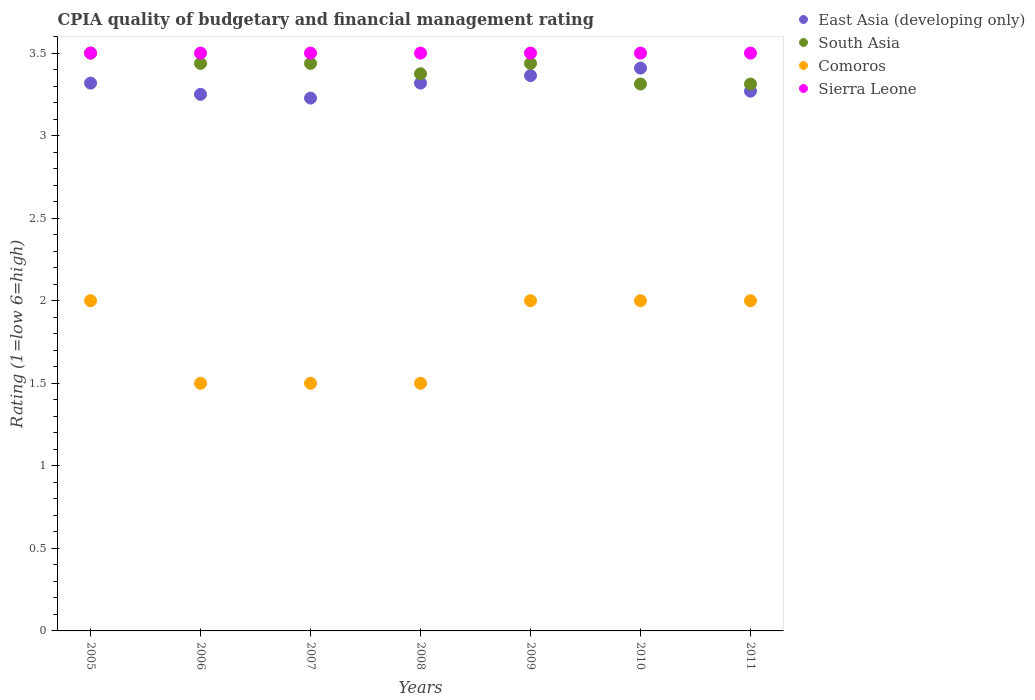How many different coloured dotlines are there?
Ensure brevity in your answer.  4. Is the number of dotlines equal to the number of legend labels?
Make the answer very short. Yes. What is the CPIA rating in East Asia (developing only) in 2008?
Your response must be concise. 3.32. Across all years, what is the maximum CPIA rating in South Asia?
Give a very brief answer. 3.5. In which year was the CPIA rating in South Asia maximum?
Offer a very short reply. 2005. In which year was the CPIA rating in Sierra Leone minimum?
Make the answer very short. 2005. What is the total CPIA rating in Sierra Leone in the graph?
Provide a short and direct response. 24.5. What is the average CPIA rating in Sierra Leone per year?
Keep it short and to the point. 3.5. In the year 2011, what is the difference between the CPIA rating in East Asia (developing only) and CPIA rating in South Asia?
Your response must be concise. -0.04. In how many years, is the CPIA rating in Sierra Leone greater than 0.7?
Offer a terse response. 7. What is the ratio of the CPIA rating in South Asia in 2008 to that in 2009?
Your answer should be very brief. 0.98. What is the difference between the highest and the second highest CPIA rating in South Asia?
Your answer should be very brief. 0.06. What is the difference between the highest and the lowest CPIA rating in South Asia?
Offer a terse response. 0.19. Is it the case that in every year, the sum of the CPIA rating in Comoros and CPIA rating in South Asia  is greater than the sum of CPIA rating in East Asia (developing only) and CPIA rating in Sierra Leone?
Offer a very short reply. No. Is it the case that in every year, the sum of the CPIA rating in East Asia (developing only) and CPIA rating in Comoros  is greater than the CPIA rating in South Asia?
Your answer should be very brief. Yes. Does the CPIA rating in Comoros monotonically increase over the years?
Your answer should be very brief. No. Is the CPIA rating in South Asia strictly less than the CPIA rating in East Asia (developing only) over the years?
Keep it short and to the point. No. How many years are there in the graph?
Your answer should be very brief. 7. What is the difference between two consecutive major ticks on the Y-axis?
Provide a succinct answer. 0.5. Are the values on the major ticks of Y-axis written in scientific E-notation?
Give a very brief answer. No. Does the graph contain grids?
Your response must be concise. No. What is the title of the graph?
Your response must be concise. CPIA quality of budgetary and financial management rating. What is the label or title of the Y-axis?
Keep it short and to the point. Rating (1=low 6=high). What is the Rating (1=low 6=high) in East Asia (developing only) in 2005?
Provide a short and direct response. 3.32. What is the Rating (1=low 6=high) of Comoros in 2005?
Provide a short and direct response. 2. What is the Rating (1=low 6=high) of Sierra Leone in 2005?
Your answer should be very brief. 3.5. What is the Rating (1=low 6=high) of East Asia (developing only) in 2006?
Provide a succinct answer. 3.25. What is the Rating (1=low 6=high) of South Asia in 2006?
Make the answer very short. 3.44. What is the Rating (1=low 6=high) in Comoros in 2006?
Your answer should be compact. 1.5. What is the Rating (1=low 6=high) in East Asia (developing only) in 2007?
Give a very brief answer. 3.23. What is the Rating (1=low 6=high) in South Asia in 2007?
Make the answer very short. 3.44. What is the Rating (1=low 6=high) in Sierra Leone in 2007?
Ensure brevity in your answer.  3.5. What is the Rating (1=low 6=high) in East Asia (developing only) in 2008?
Provide a short and direct response. 3.32. What is the Rating (1=low 6=high) of South Asia in 2008?
Provide a succinct answer. 3.38. What is the Rating (1=low 6=high) in Comoros in 2008?
Make the answer very short. 1.5. What is the Rating (1=low 6=high) of East Asia (developing only) in 2009?
Your answer should be compact. 3.36. What is the Rating (1=low 6=high) of South Asia in 2009?
Offer a very short reply. 3.44. What is the Rating (1=low 6=high) of Comoros in 2009?
Offer a very short reply. 2. What is the Rating (1=low 6=high) of Sierra Leone in 2009?
Your answer should be very brief. 3.5. What is the Rating (1=low 6=high) of East Asia (developing only) in 2010?
Keep it short and to the point. 3.41. What is the Rating (1=low 6=high) in South Asia in 2010?
Your answer should be compact. 3.31. What is the Rating (1=low 6=high) of Sierra Leone in 2010?
Give a very brief answer. 3.5. What is the Rating (1=low 6=high) of East Asia (developing only) in 2011?
Provide a succinct answer. 3.27. What is the Rating (1=low 6=high) of South Asia in 2011?
Give a very brief answer. 3.31. What is the Rating (1=low 6=high) in Sierra Leone in 2011?
Keep it short and to the point. 3.5. Across all years, what is the maximum Rating (1=low 6=high) of East Asia (developing only)?
Offer a terse response. 3.41. Across all years, what is the minimum Rating (1=low 6=high) in East Asia (developing only)?
Provide a short and direct response. 3.23. Across all years, what is the minimum Rating (1=low 6=high) of South Asia?
Offer a terse response. 3.31. What is the total Rating (1=low 6=high) of East Asia (developing only) in the graph?
Offer a terse response. 23.16. What is the total Rating (1=low 6=high) in South Asia in the graph?
Your answer should be very brief. 23.81. What is the difference between the Rating (1=low 6=high) in East Asia (developing only) in 2005 and that in 2006?
Your answer should be compact. 0.07. What is the difference between the Rating (1=low 6=high) of South Asia in 2005 and that in 2006?
Offer a very short reply. 0.06. What is the difference between the Rating (1=low 6=high) of Comoros in 2005 and that in 2006?
Your answer should be compact. 0.5. What is the difference between the Rating (1=low 6=high) in East Asia (developing only) in 2005 and that in 2007?
Provide a succinct answer. 0.09. What is the difference between the Rating (1=low 6=high) in South Asia in 2005 and that in 2007?
Your response must be concise. 0.06. What is the difference between the Rating (1=low 6=high) in Sierra Leone in 2005 and that in 2007?
Offer a very short reply. 0. What is the difference between the Rating (1=low 6=high) of East Asia (developing only) in 2005 and that in 2009?
Provide a succinct answer. -0.05. What is the difference between the Rating (1=low 6=high) in South Asia in 2005 and that in 2009?
Provide a succinct answer. 0.06. What is the difference between the Rating (1=low 6=high) in Comoros in 2005 and that in 2009?
Make the answer very short. 0. What is the difference between the Rating (1=low 6=high) in East Asia (developing only) in 2005 and that in 2010?
Your answer should be compact. -0.09. What is the difference between the Rating (1=low 6=high) in South Asia in 2005 and that in 2010?
Your answer should be compact. 0.19. What is the difference between the Rating (1=low 6=high) of Comoros in 2005 and that in 2010?
Give a very brief answer. 0. What is the difference between the Rating (1=low 6=high) of East Asia (developing only) in 2005 and that in 2011?
Offer a terse response. 0.05. What is the difference between the Rating (1=low 6=high) of South Asia in 2005 and that in 2011?
Your answer should be compact. 0.19. What is the difference between the Rating (1=low 6=high) of Comoros in 2005 and that in 2011?
Give a very brief answer. 0. What is the difference between the Rating (1=low 6=high) of East Asia (developing only) in 2006 and that in 2007?
Ensure brevity in your answer.  0.02. What is the difference between the Rating (1=low 6=high) of Sierra Leone in 2006 and that in 2007?
Ensure brevity in your answer.  0. What is the difference between the Rating (1=low 6=high) of East Asia (developing only) in 2006 and that in 2008?
Provide a short and direct response. -0.07. What is the difference between the Rating (1=low 6=high) of South Asia in 2006 and that in 2008?
Your answer should be very brief. 0.06. What is the difference between the Rating (1=low 6=high) in Comoros in 2006 and that in 2008?
Give a very brief answer. 0. What is the difference between the Rating (1=low 6=high) in Sierra Leone in 2006 and that in 2008?
Make the answer very short. 0. What is the difference between the Rating (1=low 6=high) of East Asia (developing only) in 2006 and that in 2009?
Keep it short and to the point. -0.11. What is the difference between the Rating (1=low 6=high) in South Asia in 2006 and that in 2009?
Offer a terse response. 0. What is the difference between the Rating (1=low 6=high) of Comoros in 2006 and that in 2009?
Keep it short and to the point. -0.5. What is the difference between the Rating (1=low 6=high) of Sierra Leone in 2006 and that in 2009?
Provide a short and direct response. 0. What is the difference between the Rating (1=low 6=high) in East Asia (developing only) in 2006 and that in 2010?
Make the answer very short. -0.16. What is the difference between the Rating (1=low 6=high) of Comoros in 2006 and that in 2010?
Provide a succinct answer. -0.5. What is the difference between the Rating (1=low 6=high) of Sierra Leone in 2006 and that in 2010?
Ensure brevity in your answer.  0. What is the difference between the Rating (1=low 6=high) of East Asia (developing only) in 2006 and that in 2011?
Give a very brief answer. -0.02. What is the difference between the Rating (1=low 6=high) of East Asia (developing only) in 2007 and that in 2008?
Give a very brief answer. -0.09. What is the difference between the Rating (1=low 6=high) of South Asia in 2007 and that in 2008?
Offer a terse response. 0.06. What is the difference between the Rating (1=low 6=high) in Comoros in 2007 and that in 2008?
Your response must be concise. 0. What is the difference between the Rating (1=low 6=high) in Sierra Leone in 2007 and that in 2008?
Offer a terse response. 0. What is the difference between the Rating (1=low 6=high) in East Asia (developing only) in 2007 and that in 2009?
Ensure brevity in your answer.  -0.14. What is the difference between the Rating (1=low 6=high) in South Asia in 2007 and that in 2009?
Ensure brevity in your answer.  0. What is the difference between the Rating (1=low 6=high) of Comoros in 2007 and that in 2009?
Offer a very short reply. -0.5. What is the difference between the Rating (1=low 6=high) in East Asia (developing only) in 2007 and that in 2010?
Ensure brevity in your answer.  -0.18. What is the difference between the Rating (1=low 6=high) of South Asia in 2007 and that in 2010?
Make the answer very short. 0.12. What is the difference between the Rating (1=low 6=high) of Comoros in 2007 and that in 2010?
Offer a very short reply. -0.5. What is the difference between the Rating (1=low 6=high) in Sierra Leone in 2007 and that in 2010?
Provide a short and direct response. 0. What is the difference between the Rating (1=low 6=high) of East Asia (developing only) in 2007 and that in 2011?
Keep it short and to the point. -0.04. What is the difference between the Rating (1=low 6=high) of East Asia (developing only) in 2008 and that in 2009?
Give a very brief answer. -0.05. What is the difference between the Rating (1=low 6=high) of South Asia in 2008 and that in 2009?
Your answer should be very brief. -0.06. What is the difference between the Rating (1=low 6=high) in East Asia (developing only) in 2008 and that in 2010?
Your answer should be very brief. -0.09. What is the difference between the Rating (1=low 6=high) in South Asia in 2008 and that in 2010?
Offer a very short reply. 0.06. What is the difference between the Rating (1=low 6=high) of East Asia (developing only) in 2008 and that in 2011?
Offer a very short reply. 0.05. What is the difference between the Rating (1=low 6=high) in South Asia in 2008 and that in 2011?
Give a very brief answer. 0.06. What is the difference between the Rating (1=low 6=high) of Comoros in 2008 and that in 2011?
Make the answer very short. -0.5. What is the difference between the Rating (1=low 6=high) in East Asia (developing only) in 2009 and that in 2010?
Give a very brief answer. -0.05. What is the difference between the Rating (1=low 6=high) in South Asia in 2009 and that in 2010?
Provide a succinct answer. 0.12. What is the difference between the Rating (1=low 6=high) of East Asia (developing only) in 2009 and that in 2011?
Ensure brevity in your answer.  0.09. What is the difference between the Rating (1=low 6=high) of Comoros in 2009 and that in 2011?
Give a very brief answer. 0. What is the difference between the Rating (1=low 6=high) of Sierra Leone in 2009 and that in 2011?
Make the answer very short. 0. What is the difference between the Rating (1=low 6=high) of East Asia (developing only) in 2010 and that in 2011?
Make the answer very short. 0.14. What is the difference between the Rating (1=low 6=high) of Comoros in 2010 and that in 2011?
Make the answer very short. 0. What is the difference between the Rating (1=low 6=high) of Sierra Leone in 2010 and that in 2011?
Keep it short and to the point. 0. What is the difference between the Rating (1=low 6=high) in East Asia (developing only) in 2005 and the Rating (1=low 6=high) in South Asia in 2006?
Provide a succinct answer. -0.12. What is the difference between the Rating (1=low 6=high) of East Asia (developing only) in 2005 and the Rating (1=low 6=high) of Comoros in 2006?
Offer a very short reply. 1.82. What is the difference between the Rating (1=low 6=high) in East Asia (developing only) in 2005 and the Rating (1=low 6=high) in Sierra Leone in 2006?
Provide a succinct answer. -0.18. What is the difference between the Rating (1=low 6=high) in South Asia in 2005 and the Rating (1=low 6=high) in Comoros in 2006?
Ensure brevity in your answer.  2. What is the difference between the Rating (1=low 6=high) in South Asia in 2005 and the Rating (1=low 6=high) in Sierra Leone in 2006?
Your answer should be very brief. 0. What is the difference between the Rating (1=low 6=high) in Comoros in 2005 and the Rating (1=low 6=high) in Sierra Leone in 2006?
Give a very brief answer. -1.5. What is the difference between the Rating (1=low 6=high) of East Asia (developing only) in 2005 and the Rating (1=low 6=high) of South Asia in 2007?
Your answer should be very brief. -0.12. What is the difference between the Rating (1=low 6=high) in East Asia (developing only) in 2005 and the Rating (1=low 6=high) in Comoros in 2007?
Ensure brevity in your answer.  1.82. What is the difference between the Rating (1=low 6=high) of East Asia (developing only) in 2005 and the Rating (1=low 6=high) of Sierra Leone in 2007?
Offer a very short reply. -0.18. What is the difference between the Rating (1=low 6=high) in South Asia in 2005 and the Rating (1=low 6=high) in Comoros in 2007?
Your answer should be very brief. 2. What is the difference between the Rating (1=low 6=high) of Comoros in 2005 and the Rating (1=low 6=high) of Sierra Leone in 2007?
Provide a succinct answer. -1.5. What is the difference between the Rating (1=low 6=high) of East Asia (developing only) in 2005 and the Rating (1=low 6=high) of South Asia in 2008?
Keep it short and to the point. -0.06. What is the difference between the Rating (1=low 6=high) of East Asia (developing only) in 2005 and the Rating (1=low 6=high) of Comoros in 2008?
Keep it short and to the point. 1.82. What is the difference between the Rating (1=low 6=high) of East Asia (developing only) in 2005 and the Rating (1=low 6=high) of Sierra Leone in 2008?
Ensure brevity in your answer.  -0.18. What is the difference between the Rating (1=low 6=high) of South Asia in 2005 and the Rating (1=low 6=high) of Sierra Leone in 2008?
Provide a short and direct response. 0. What is the difference between the Rating (1=low 6=high) in East Asia (developing only) in 2005 and the Rating (1=low 6=high) in South Asia in 2009?
Your answer should be very brief. -0.12. What is the difference between the Rating (1=low 6=high) of East Asia (developing only) in 2005 and the Rating (1=low 6=high) of Comoros in 2009?
Give a very brief answer. 1.32. What is the difference between the Rating (1=low 6=high) in East Asia (developing only) in 2005 and the Rating (1=low 6=high) in Sierra Leone in 2009?
Provide a short and direct response. -0.18. What is the difference between the Rating (1=low 6=high) in South Asia in 2005 and the Rating (1=low 6=high) in Comoros in 2009?
Make the answer very short. 1.5. What is the difference between the Rating (1=low 6=high) of South Asia in 2005 and the Rating (1=low 6=high) of Sierra Leone in 2009?
Your answer should be compact. 0. What is the difference between the Rating (1=low 6=high) of East Asia (developing only) in 2005 and the Rating (1=low 6=high) of South Asia in 2010?
Make the answer very short. 0.01. What is the difference between the Rating (1=low 6=high) of East Asia (developing only) in 2005 and the Rating (1=low 6=high) of Comoros in 2010?
Offer a very short reply. 1.32. What is the difference between the Rating (1=low 6=high) of East Asia (developing only) in 2005 and the Rating (1=low 6=high) of Sierra Leone in 2010?
Offer a terse response. -0.18. What is the difference between the Rating (1=low 6=high) in Comoros in 2005 and the Rating (1=low 6=high) in Sierra Leone in 2010?
Your answer should be very brief. -1.5. What is the difference between the Rating (1=low 6=high) of East Asia (developing only) in 2005 and the Rating (1=low 6=high) of South Asia in 2011?
Make the answer very short. 0.01. What is the difference between the Rating (1=low 6=high) of East Asia (developing only) in 2005 and the Rating (1=low 6=high) of Comoros in 2011?
Offer a very short reply. 1.32. What is the difference between the Rating (1=low 6=high) of East Asia (developing only) in 2005 and the Rating (1=low 6=high) of Sierra Leone in 2011?
Make the answer very short. -0.18. What is the difference between the Rating (1=low 6=high) of East Asia (developing only) in 2006 and the Rating (1=low 6=high) of South Asia in 2007?
Your answer should be compact. -0.19. What is the difference between the Rating (1=low 6=high) in South Asia in 2006 and the Rating (1=low 6=high) in Comoros in 2007?
Offer a terse response. 1.94. What is the difference between the Rating (1=low 6=high) in South Asia in 2006 and the Rating (1=low 6=high) in Sierra Leone in 2007?
Provide a succinct answer. -0.06. What is the difference between the Rating (1=low 6=high) of East Asia (developing only) in 2006 and the Rating (1=low 6=high) of South Asia in 2008?
Provide a short and direct response. -0.12. What is the difference between the Rating (1=low 6=high) of South Asia in 2006 and the Rating (1=low 6=high) of Comoros in 2008?
Provide a short and direct response. 1.94. What is the difference between the Rating (1=low 6=high) in South Asia in 2006 and the Rating (1=low 6=high) in Sierra Leone in 2008?
Provide a short and direct response. -0.06. What is the difference between the Rating (1=low 6=high) of East Asia (developing only) in 2006 and the Rating (1=low 6=high) of South Asia in 2009?
Make the answer very short. -0.19. What is the difference between the Rating (1=low 6=high) in East Asia (developing only) in 2006 and the Rating (1=low 6=high) in Comoros in 2009?
Offer a very short reply. 1.25. What is the difference between the Rating (1=low 6=high) in South Asia in 2006 and the Rating (1=low 6=high) in Comoros in 2009?
Your answer should be compact. 1.44. What is the difference between the Rating (1=low 6=high) in South Asia in 2006 and the Rating (1=low 6=high) in Sierra Leone in 2009?
Make the answer very short. -0.06. What is the difference between the Rating (1=low 6=high) of Comoros in 2006 and the Rating (1=low 6=high) of Sierra Leone in 2009?
Provide a succinct answer. -2. What is the difference between the Rating (1=low 6=high) of East Asia (developing only) in 2006 and the Rating (1=low 6=high) of South Asia in 2010?
Give a very brief answer. -0.06. What is the difference between the Rating (1=low 6=high) of South Asia in 2006 and the Rating (1=low 6=high) of Comoros in 2010?
Offer a terse response. 1.44. What is the difference between the Rating (1=low 6=high) of South Asia in 2006 and the Rating (1=low 6=high) of Sierra Leone in 2010?
Your answer should be very brief. -0.06. What is the difference between the Rating (1=low 6=high) in East Asia (developing only) in 2006 and the Rating (1=low 6=high) in South Asia in 2011?
Your answer should be very brief. -0.06. What is the difference between the Rating (1=low 6=high) in East Asia (developing only) in 2006 and the Rating (1=low 6=high) in Sierra Leone in 2011?
Provide a short and direct response. -0.25. What is the difference between the Rating (1=low 6=high) of South Asia in 2006 and the Rating (1=low 6=high) of Comoros in 2011?
Give a very brief answer. 1.44. What is the difference between the Rating (1=low 6=high) of South Asia in 2006 and the Rating (1=low 6=high) of Sierra Leone in 2011?
Give a very brief answer. -0.06. What is the difference between the Rating (1=low 6=high) of East Asia (developing only) in 2007 and the Rating (1=low 6=high) of South Asia in 2008?
Provide a short and direct response. -0.15. What is the difference between the Rating (1=low 6=high) of East Asia (developing only) in 2007 and the Rating (1=low 6=high) of Comoros in 2008?
Your answer should be compact. 1.73. What is the difference between the Rating (1=low 6=high) of East Asia (developing only) in 2007 and the Rating (1=low 6=high) of Sierra Leone in 2008?
Provide a succinct answer. -0.27. What is the difference between the Rating (1=low 6=high) of South Asia in 2007 and the Rating (1=low 6=high) of Comoros in 2008?
Provide a succinct answer. 1.94. What is the difference between the Rating (1=low 6=high) in South Asia in 2007 and the Rating (1=low 6=high) in Sierra Leone in 2008?
Provide a short and direct response. -0.06. What is the difference between the Rating (1=low 6=high) in East Asia (developing only) in 2007 and the Rating (1=low 6=high) in South Asia in 2009?
Offer a very short reply. -0.21. What is the difference between the Rating (1=low 6=high) in East Asia (developing only) in 2007 and the Rating (1=low 6=high) in Comoros in 2009?
Ensure brevity in your answer.  1.23. What is the difference between the Rating (1=low 6=high) of East Asia (developing only) in 2007 and the Rating (1=low 6=high) of Sierra Leone in 2009?
Ensure brevity in your answer.  -0.27. What is the difference between the Rating (1=low 6=high) of South Asia in 2007 and the Rating (1=low 6=high) of Comoros in 2009?
Your answer should be compact. 1.44. What is the difference between the Rating (1=low 6=high) of South Asia in 2007 and the Rating (1=low 6=high) of Sierra Leone in 2009?
Provide a short and direct response. -0.06. What is the difference between the Rating (1=low 6=high) in Comoros in 2007 and the Rating (1=low 6=high) in Sierra Leone in 2009?
Your answer should be very brief. -2. What is the difference between the Rating (1=low 6=high) in East Asia (developing only) in 2007 and the Rating (1=low 6=high) in South Asia in 2010?
Provide a succinct answer. -0.09. What is the difference between the Rating (1=low 6=high) in East Asia (developing only) in 2007 and the Rating (1=low 6=high) in Comoros in 2010?
Keep it short and to the point. 1.23. What is the difference between the Rating (1=low 6=high) of East Asia (developing only) in 2007 and the Rating (1=low 6=high) of Sierra Leone in 2010?
Your answer should be very brief. -0.27. What is the difference between the Rating (1=low 6=high) in South Asia in 2007 and the Rating (1=low 6=high) in Comoros in 2010?
Provide a succinct answer. 1.44. What is the difference between the Rating (1=low 6=high) in South Asia in 2007 and the Rating (1=low 6=high) in Sierra Leone in 2010?
Your response must be concise. -0.06. What is the difference between the Rating (1=low 6=high) in East Asia (developing only) in 2007 and the Rating (1=low 6=high) in South Asia in 2011?
Offer a terse response. -0.09. What is the difference between the Rating (1=low 6=high) in East Asia (developing only) in 2007 and the Rating (1=low 6=high) in Comoros in 2011?
Offer a terse response. 1.23. What is the difference between the Rating (1=low 6=high) of East Asia (developing only) in 2007 and the Rating (1=low 6=high) of Sierra Leone in 2011?
Make the answer very short. -0.27. What is the difference between the Rating (1=low 6=high) of South Asia in 2007 and the Rating (1=low 6=high) of Comoros in 2011?
Provide a succinct answer. 1.44. What is the difference between the Rating (1=low 6=high) of South Asia in 2007 and the Rating (1=low 6=high) of Sierra Leone in 2011?
Give a very brief answer. -0.06. What is the difference between the Rating (1=low 6=high) of East Asia (developing only) in 2008 and the Rating (1=low 6=high) of South Asia in 2009?
Provide a succinct answer. -0.12. What is the difference between the Rating (1=low 6=high) in East Asia (developing only) in 2008 and the Rating (1=low 6=high) in Comoros in 2009?
Offer a terse response. 1.32. What is the difference between the Rating (1=low 6=high) of East Asia (developing only) in 2008 and the Rating (1=low 6=high) of Sierra Leone in 2009?
Make the answer very short. -0.18. What is the difference between the Rating (1=low 6=high) in South Asia in 2008 and the Rating (1=low 6=high) in Comoros in 2009?
Offer a terse response. 1.38. What is the difference between the Rating (1=low 6=high) of South Asia in 2008 and the Rating (1=low 6=high) of Sierra Leone in 2009?
Give a very brief answer. -0.12. What is the difference between the Rating (1=low 6=high) of Comoros in 2008 and the Rating (1=low 6=high) of Sierra Leone in 2009?
Your answer should be compact. -2. What is the difference between the Rating (1=low 6=high) in East Asia (developing only) in 2008 and the Rating (1=low 6=high) in South Asia in 2010?
Offer a very short reply. 0.01. What is the difference between the Rating (1=low 6=high) in East Asia (developing only) in 2008 and the Rating (1=low 6=high) in Comoros in 2010?
Your response must be concise. 1.32. What is the difference between the Rating (1=low 6=high) of East Asia (developing only) in 2008 and the Rating (1=low 6=high) of Sierra Leone in 2010?
Your answer should be compact. -0.18. What is the difference between the Rating (1=low 6=high) of South Asia in 2008 and the Rating (1=low 6=high) of Comoros in 2010?
Give a very brief answer. 1.38. What is the difference between the Rating (1=low 6=high) in South Asia in 2008 and the Rating (1=low 6=high) in Sierra Leone in 2010?
Your answer should be very brief. -0.12. What is the difference between the Rating (1=low 6=high) of Comoros in 2008 and the Rating (1=low 6=high) of Sierra Leone in 2010?
Your answer should be compact. -2. What is the difference between the Rating (1=low 6=high) in East Asia (developing only) in 2008 and the Rating (1=low 6=high) in South Asia in 2011?
Offer a very short reply. 0.01. What is the difference between the Rating (1=low 6=high) of East Asia (developing only) in 2008 and the Rating (1=low 6=high) of Comoros in 2011?
Offer a terse response. 1.32. What is the difference between the Rating (1=low 6=high) in East Asia (developing only) in 2008 and the Rating (1=low 6=high) in Sierra Leone in 2011?
Ensure brevity in your answer.  -0.18. What is the difference between the Rating (1=low 6=high) of South Asia in 2008 and the Rating (1=low 6=high) of Comoros in 2011?
Offer a terse response. 1.38. What is the difference between the Rating (1=low 6=high) in South Asia in 2008 and the Rating (1=low 6=high) in Sierra Leone in 2011?
Your response must be concise. -0.12. What is the difference between the Rating (1=low 6=high) in Comoros in 2008 and the Rating (1=low 6=high) in Sierra Leone in 2011?
Offer a terse response. -2. What is the difference between the Rating (1=low 6=high) in East Asia (developing only) in 2009 and the Rating (1=low 6=high) in South Asia in 2010?
Ensure brevity in your answer.  0.05. What is the difference between the Rating (1=low 6=high) of East Asia (developing only) in 2009 and the Rating (1=low 6=high) of Comoros in 2010?
Keep it short and to the point. 1.36. What is the difference between the Rating (1=low 6=high) of East Asia (developing only) in 2009 and the Rating (1=low 6=high) of Sierra Leone in 2010?
Ensure brevity in your answer.  -0.14. What is the difference between the Rating (1=low 6=high) in South Asia in 2009 and the Rating (1=low 6=high) in Comoros in 2010?
Provide a short and direct response. 1.44. What is the difference between the Rating (1=low 6=high) in South Asia in 2009 and the Rating (1=low 6=high) in Sierra Leone in 2010?
Provide a short and direct response. -0.06. What is the difference between the Rating (1=low 6=high) of East Asia (developing only) in 2009 and the Rating (1=low 6=high) of South Asia in 2011?
Offer a very short reply. 0.05. What is the difference between the Rating (1=low 6=high) of East Asia (developing only) in 2009 and the Rating (1=low 6=high) of Comoros in 2011?
Ensure brevity in your answer.  1.36. What is the difference between the Rating (1=low 6=high) of East Asia (developing only) in 2009 and the Rating (1=low 6=high) of Sierra Leone in 2011?
Offer a terse response. -0.14. What is the difference between the Rating (1=low 6=high) of South Asia in 2009 and the Rating (1=low 6=high) of Comoros in 2011?
Your answer should be very brief. 1.44. What is the difference between the Rating (1=low 6=high) of South Asia in 2009 and the Rating (1=low 6=high) of Sierra Leone in 2011?
Provide a succinct answer. -0.06. What is the difference between the Rating (1=low 6=high) of East Asia (developing only) in 2010 and the Rating (1=low 6=high) of South Asia in 2011?
Provide a succinct answer. 0.1. What is the difference between the Rating (1=low 6=high) of East Asia (developing only) in 2010 and the Rating (1=low 6=high) of Comoros in 2011?
Your answer should be compact. 1.41. What is the difference between the Rating (1=low 6=high) of East Asia (developing only) in 2010 and the Rating (1=low 6=high) of Sierra Leone in 2011?
Make the answer very short. -0.09. What is the difference between the Rating (1=low 6=high) in South Asia in 2010 and the Rating (1=low 6=high) in Comoros in 2011?
Your response must be concise. 1.31. What is the difference between the Rating (1=low 6=high) in South Asia in 2010 and the Rating (1=low 6=high) in Sierra Leone in 2011?
Provide a succinct answer. -0.19. What is the difference between the Rating (1=low 6=high) of Comoros in 2010 and the Rating (1=low 6=high) of Sierra Leone in 2011?
Provide a succinct answer. -1.5. What is the average Rating (1=low 6=high) of East Asia (developing only) per year?
Give a very brief answer. 3.31. What is the average Rating (1=low 6=high) of South Asia per year?
Offer a terse response. 3.4. What is the average Rating (1=low 6=high) of Comoros per year?
Your answer should be very brief. 1.79. What is the average Rating (1=low 6=high) in Sierra Leone per year?
Offer a terse response. 3.5. In the year 2005, what is the difference between the Rating (1=low 6=high) in East Asia (developing only) and Rating (1=low 6=high) in South Asia?
Keep it short and to the point. -0.18. In the year 2005, what is the difference between the Rating (1=low 6=high) of East Asia (developing only) and Rating (1=low 6=high) of Comoros?
Give a very brief answer. 1.32. In the year 2005, what is the difference between the Rating (1=low 6=high) in East Asia (developing only) and Rating (1=low 6=high) in Sierra Leone?
Make the answer very short. -0.18. In the year 2005, what is the difference between the Rating (1=low 6=high) of Comoros and Rating (1=low 6=high) of Sierra Leone?
Provide a succinct answer. -1.5. In the year 2006, what is the difference between the Rating (1=low 6=high) in East Asia (developing only) and Rating (1=low 6=high) in South Asia?
Make the answer very short. -0.19. In the year 2006, what is the difference between the Rating (1=low 6=high) of East Asia (developing only) and Rating (1=low 6=high) of Sierra Leone?
Ensure brevity in your answer.  -0.25. In the year 2006, what is the difference between the Rating (1=low 6=high) of South Asia and Rating (1=low 6=high) of Comoros?
Make the answer very short. 1.94. In the year 2006, what is the difference between the Rating (1=low 6=high) of South Asia and Rating (1=low 6=high) of Sierra Leone?
Keep it short and to the point. -0.06. In the year 2007, what is the difference between the Rating (1=low 6=high) in East Asia (developing only) and Rating (1=low 6=high) in South Asia?
Offer a terse response. -0.21. In the year 2007, what is the difference between the Rating (1=low 6=high) of East Asia (developing only) and Rating (1=low 6=high) of Comoros?
Provide a succinct answer. 1.73. In the year 2007, what is the difference between the Rating (1=low 6=high) of East Asia (developing only) and Rating (1=low 6=high) of Sierra Leone?
Provide a short and direct response. -0.27. In the year 2007, what is the difference between the Rating (1=low 6=high) of South Asia and Rating (1=low 6=high) of Comoros?
Give a very brief answer. 1.94. In the year 2007, what is the difference between the Rating (1=low 6=high) of South Asia and Rating (1=low 6=high) of Sierra Leone?
Provide a short and direct response. -0.06. In the year 2008, what is the difference between the Rating (1=low 6=high) of East Asia (developing only) and Rating (1=low 6=high) of South Asia?
Offer a terse response. -0.06. In the year 2008, what is the difference between the Rating (1=low 6=high) of East Asia (developing only) and Rating (1=low 6=high) of Comoros?
Your response must be concise. 1.82. In the year 2008, what is the difference between the Rating (1=low 6=high) in East Asia (developing only) and Rating (1=low 6=high) in Sierra Leone?
Keep it short and to the point. -0.18. In the year 2008, what is the difference between the Rating (1=low 6=high) of South Asia and Rating (1=low 6=high) of Comoros?
Give a very brief answer. 1.88. In the year 2008, what is the difference between the Rating (1=low 6=high) of South Asia and Rating (1=low 6=high) of Sierra Leone?
Your answer should be compact. -0.12. In the year 2009, what is the difference between the Rating (1=low 6=high) of East Asia (developing only) and Rating (1=low 6=high) of South Asia?
Make the answer very short. -0.07. In the year 2009, what is the difference between the Rating (1=low 6=high) of East Asia (developing only) and Rating (1=low 6=high) of Comoros?
Your answer should be very brief. 1.36. In the year 2009, what is the difference between the Rating (1=low 6=high) in East Asia (developing only) and Rating (1=low 6=high) in Sierra Leone?
Your answer should be compact. -0.14. In the year 2009, what is the difference between the Rating (1=low 6=high) of South Asia and Rating (1=low 6=high) of Comoros?
Offer a very short reply. 1.44. In the year 2009, what is the difference between the Rating (1=low 6=high) of South Asia and Rating (1=low 6=high) of Sierra Leone?
Make the answer very short. -0.06. In the year 2010, what is the difference between the Rating (1=low 6=high) in East Asia (developing only) and Rating (1=low 6=high) in South Asia?
Provide a short and direct response. 0.1. In the year 2010, what is the difference between the Rating (1=low 6=high) in East Asia (developing only) and Rating (1=low 6=high) in Comoros?
Ensure brevity in your answer.  1.41. In the year 2010, what is the difference between the Rating (1=low 6=high) of East Asia (developing only) and Rating (1=low 6=high) of Sierra Leone?
Your response must be concise. -0.09. In the year 2010, what is the difference between the Rating (1=low 6=high) of South Asia and Rating (1=low 6=high) of Comoros?
Make the answer very short. 1.31. In the year 2010, what is the difference between the Rating (1=low 6=high) of South Asia and Rating (1=low 6=high) of Sierra Leone?
Ensure brevity in your answer.  -0.19. In the year 2011, what is the difference between the Rating (1=low 6=high) in East Asia (developing only) and Rating (1=low 6=high) in South Asia?
Offer a terse response. -0.04. In the year 2011, what is the difference between the Rating (1=low 6=high) in East Asia (developing only) and Rating (1=low 6=high) in Comoros?
Make the answer very short. 1.27. In the year 2011, what is the difference between the Rating (1=low 6=high) of East Asia (developing only) and Rating (1=low 6=high) of Sierra Leone?
Give a very brief answer. -0.23. In the year 2011, what is the difference between the Rating (1=low 6=high) in South Asia and Rating (1=low 6=high) in Comoros?
Your response must be concise. 1.31. In the year 2011, what is the difference between the Rating (1=low 6=high) of South Asia and Rating (1=low 6=high) of Sierra Leone?
Your response must be concise. -0.19. What is the ratio of the Rating (1=low 6=high) in East Asia (developing only) in 2005 to that in 2006?
Make the answer very short. 1.02. What is the ratio of the Rating (1=low 6=high) in South Asia in 2005 to that in 2006?
Give a very brief answer. 1.02. What is the ratio of the Rating (1=low 6=high) in East Asia (developing only) in 2005 to that in 2007?
Your response must be concise. 1.03. What is the ratio of the Rating (1=low 6=high) of South Asia in 2005 to that in 2007?
Your response must be concise. 1.02. What is the ratio of the Rating (1=low 6=high) in Comoros in 2005 to that in 2007?
Keep it short and to the point. 1.33. What is the ratio of the Rating (1=low 6=high) in Sierra Leone in 2005 to that in 2007?
Your answer should be compact. 1. What is the ratio of the Rating (1=low 6=high) of East Asia (developing only) in 2005 to that in 2008?
Your answer should be compact. 1. What is the ratio of the Rating (1=low 6=high) in South Asia in 2005 to that in 2008?
Your answer should be very brief. 1.04. What is the ratio of the Rating (1=low 6=high) in East Asia (developing only) in 2005 to that in 2009?
Offer a very short reply. 0.99. What is the ratio of the Rating (1=low 6=high) of South Asia in 2005 to that in 2009?
Keep it short and to the point. 1.02. What is the ratio of the Rating (1=low 6=high) of East Asia (developing only) in 2005 to that in 2010?
Give a very brief answer. 0.97. What is the ratio of the Rating (1=low 6=high) of South Asia in 2005 to that in 2010?
Provide a succinct answer. 1.06. What is the ratio of the Rating (1=low 6=high) of Comoros in 2005 to that in 2010?
Your response must be concise. 1. What is the ratio of the Rating (1=low 6=high) of South Asia in 2005 to that in 2011?
Your answer should be compact. 1.06. What is the ratio of the Rating (1=low 6=high) in East Asia (developing only) in 2006 to that in 2007?
Make the answer very short. 1.01. What is the ratio of the Rating (1=low 6=high) of Comoros in 2006 to that in 2007?
Your response must be concise. 1. What is the ratio of the Rating (1=low 6=high) of East Asia (developing only) in 2006 to that in 2008?
Offer a very short reply. 0.98. What is the ratio of the Rating (1=low 6=high) of South Asia in 2006 to that in 2008?
Offer a terse response. 1.02. What is the ratio of the Rating (1=low 6=high) of Comoros in 2006 to that in 2008?
Your answer should be very brief. 1. What is the ratio of the Rating (1=low 6=high) in East Asia (developing only) in 2006 to that in 2009?
Keep it short and to the point. 0.97. What is the ratio of the Rating (1=low 6=high) of Comoros in 2006 to that in 2009?
Make the answer very short. 0.75. What is the ratio of the Rating (1=low 6=high) of Sierra Leone in 2006 to that in 2009?
Your answer should be very brief. 1. What is the ratio of the Rating (1=low 6=high) of East Asia (developing only) in 2006 to that in 2010?
Your answer should be very brief. 0.95. What is the ratio of the Rating (1=low 6=high) in South Asia in 2006 to that in 2010?
Offer a very short reply. 1.04. What is the ratio of the Rating (1=low 6=high) of East Asia (developing only) in 2006 to that in 2011?
Your answer should be compact. 0.99. What is the ratio of the Rating (1=low 6=high) of South Asia in 2006 to that in 2011?
Ensure brevity in your answer.  1.04. What is the ratio of the Rating (1=low 6=high) in Comoros in 2006 to that in 2011?
Offer a very short reply. 0.75. What is the ratio of the Rating (1=low 6=high) of East Asia (developing only) in 2007 to that in 2008?
Your answer should be compact. 0.97. What is the ratio of the Rating (1=low 6=high) in South Asia in 2007 to that in 2008?
Provide a succinct answer. 1.02. What is the ratio of the Rating (1=low 6=high) in Comoros in 2007 to that in 2008?
Your response must be concise. 1. What is the ratio of the Rating (1=low 6=high) of East Asia (developing only) in 2007 to that in 2009?
Your response must be concise. 0.96. What is the ratio of the Rating (1=low 6=high) in South Asia in 2007 to that in 2009?
Make the answer very short. 1. What is the ratio of the Rating (1=low 6=high) of East Asia (developing only) in 2007 to that in 2010?
Give a very brief answer. 0.95. What is the ratio of the Rating (1=low 6=high) in South Asia in 2007 to that in 2010?
Your answer should be compact. 1.04. What is the ratio of the Rating (1=low 6=high) in Sierra Leone in 2007 to that in 2010?
Ensure brevity in your answer.  1. What is the ratio of the Rating (1=low 6=high) in East Asia (developing only) in 2007 to that in 2011?
Make the answer very short. 0.99. What is the ratio of the Rating (1=low 6=high) in South Asia in 2007 to that in 2011?
Offer a very short reply. 1.04. What is the ratio of the Rating (1=low 6=high) of Sierra Leone in 2007 to that in 2011?
Ensure brevity in your answer.  1. What is the ratio of the Rating (1=low 6=high) in East Asia (developing only) in 2008 to that in 2009?
Offer a very short reply. 0.99. What is the ratio of the Rating (1=low 6=high) of South Asia in 2008 to that in 2009?
Your response must be concise. 0.98. What is the ratio of the Rating (1=low 6=high) of Comoros in 2008 to that in 2009?
Ensure brevity in your answer.  0.75. What is the ratio of the Rating (1=low 6=high) in Sierra Leone in 2008 to that in 2009?
Make the answer very short. 1. What is the ratio of the Rating (1=low 6=high) in East Asia (developing only) in 2008 to that in 2010?
Provide a short and direct response. 0.97. What is the ratio of the Rating (1=low 6=high) in South Asia in 2008 to that in 2010?
Make the answer very short. 1.02. What is the ratio of the Rating (1=low 6=high) of East Asia (developing only) in 2008 to that in 2011?
Your answer should be very brief. 1.01. What is the ratio of the Rating (1=low 6=high) of South Asia in 2008 to that in 2011?
Offer a terse response. 1.02. What is the ratio of the Rating (1=low 6=high) of Comoros in 2008 to that in 2011?
Give a very brief answer. 0.75. What is the ratio of the Rating (1=low 6=high) in East Asia (developing only) in 2009 to that in 2010?
Give a very brief answer. 0.99. What is the ratio of the Rating (1=low 6=high) in South Asia in 2009 to that in 2010?
Offer a terse response. 1.04. What is the ratio of the Rating (1=low 6=high) of Comoros in 2009 to that in 2010?
Give a very brief answer. 1. What is the ratio of the Rating (1=low 6=high) in East Asia (developing only) in 2009 to that in 2011?
Provide a succinct answer. 1.03. What is the ratio of the Rating (1=low 6=high) in South Asia in 2009 to that in 2011?
Offer a terse response. 1.04. What is the ratio of the Rating (1=low 6=high) of Comoros in 2009 to that in 2011?
Your answer should be compact. 1. What is the ratio of the Rating (1=low 6=high) of Sierra Leone in 2009 to that in 2011?
Offer a terse response. 1. What is the ratio of the Rating (1=low 6=high) in East Asia (developing only) in 2010 to that in 2011?
Your response must be concise. 1.04. What is the ratio of the Rating (1=low 6=high) in South Asia in 2010 to that in 2011?
Give a very brief answer. 1. What is the ratio of the Rating (1=low 6=high) in Comoros in 2010 to that in 2011?
Provide a short and direct response. 1. What is the difference between the highest and the second highest Rating (1=low 6=high) in East Asia (developing only)?
Give a very brief answer. 0.05. What is the difference between the highest and the second highest Rating (1=low 6=high) in South Asia?
Your answer should be very brief. 0.06. What is the difference between the highest and the lowest Rating (1=low 6=high) in East Asia (developing only)?
Your answer should be very brief. 0.18. What is the difference between the highest and the lowest Rating (1=low 6=high) in South Asia?
Provide a short and direct response. 0.19. 